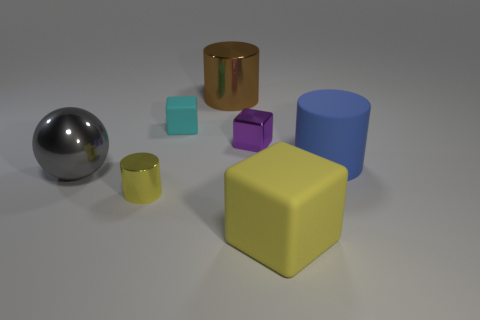Add 1 balls. How many objects exist? 8 Subtract all cylinders. How many objects are left? 4 Subtract all yellow matte balls. Subtract all tiny matte cubes. How many objects are left? 6 Add 6 big yellow blocks. How many big yellow blocks are left? 7 Add 3 cyan objects. How many cyan objects exist? 4 Subtract 0 purple cylinders. How many objects are left? 7 